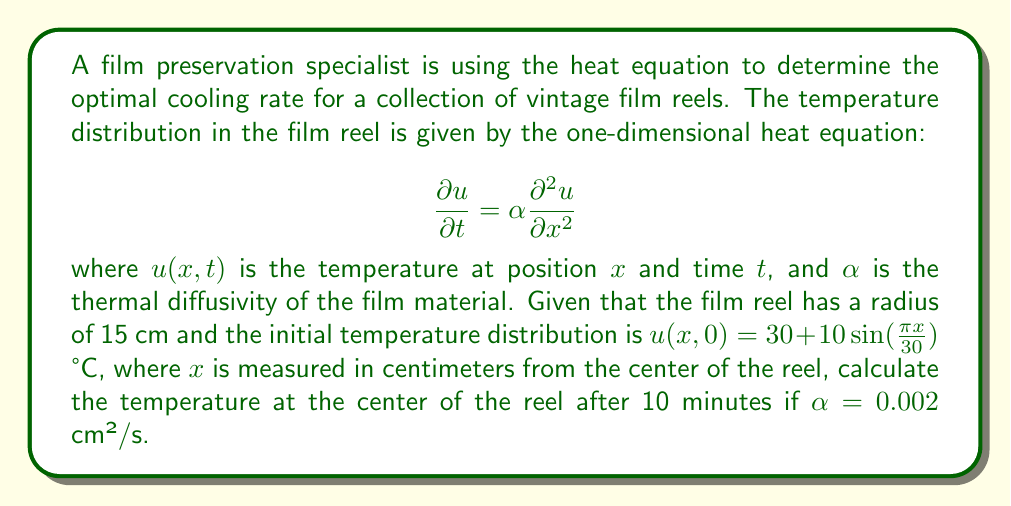What is the answer to this math problem? To solve this problem, we need to use the solution to the one-dimensional heat equation with the given initial condition. The general solution is:

$$u(x,t) = \sum_{n=1}^{\infty} B_n \sin(\frac{n\pi x}{L})e^{-\alpha(\frac{n\pi}{L})^2t}$$

where $L$ is the length of the domain (in this case, the diameter of the reel, 30 cm).

Step 1: Identify the initial condition.
$u(x,0) = 30 + 10\sin(\frac{\pi x}{30})$ °C

Step 2: Compare the initial condition with the general solution to find $B_n$.
We can see that $n=1$ and $B_1 = 10$. All other $B_n = 0$ for $n > 1$.

Step 3: Write the specific solution for this problem.
$$u(x,t) = 30 + 10\sin(\frac{\pi x}{30})e^{-\alpha(\frac{\pi}{30})^2t}$$

Step 4: Calculate the temperature at the center ($x=0$) after 10 minutes ($t=600$ s).
$$u(0,600) = 30 + 10\sin(0)e^{-0.002(\frac{\pi}{30})^2(600)}$$

Step 5: Simplify and calculate.
$$u(0,600) = 30 + 0 = 30$$ °C

Therefore, the temperature at the center of the reel after 10 minutes remains 30°C.
Answer: 30°C 